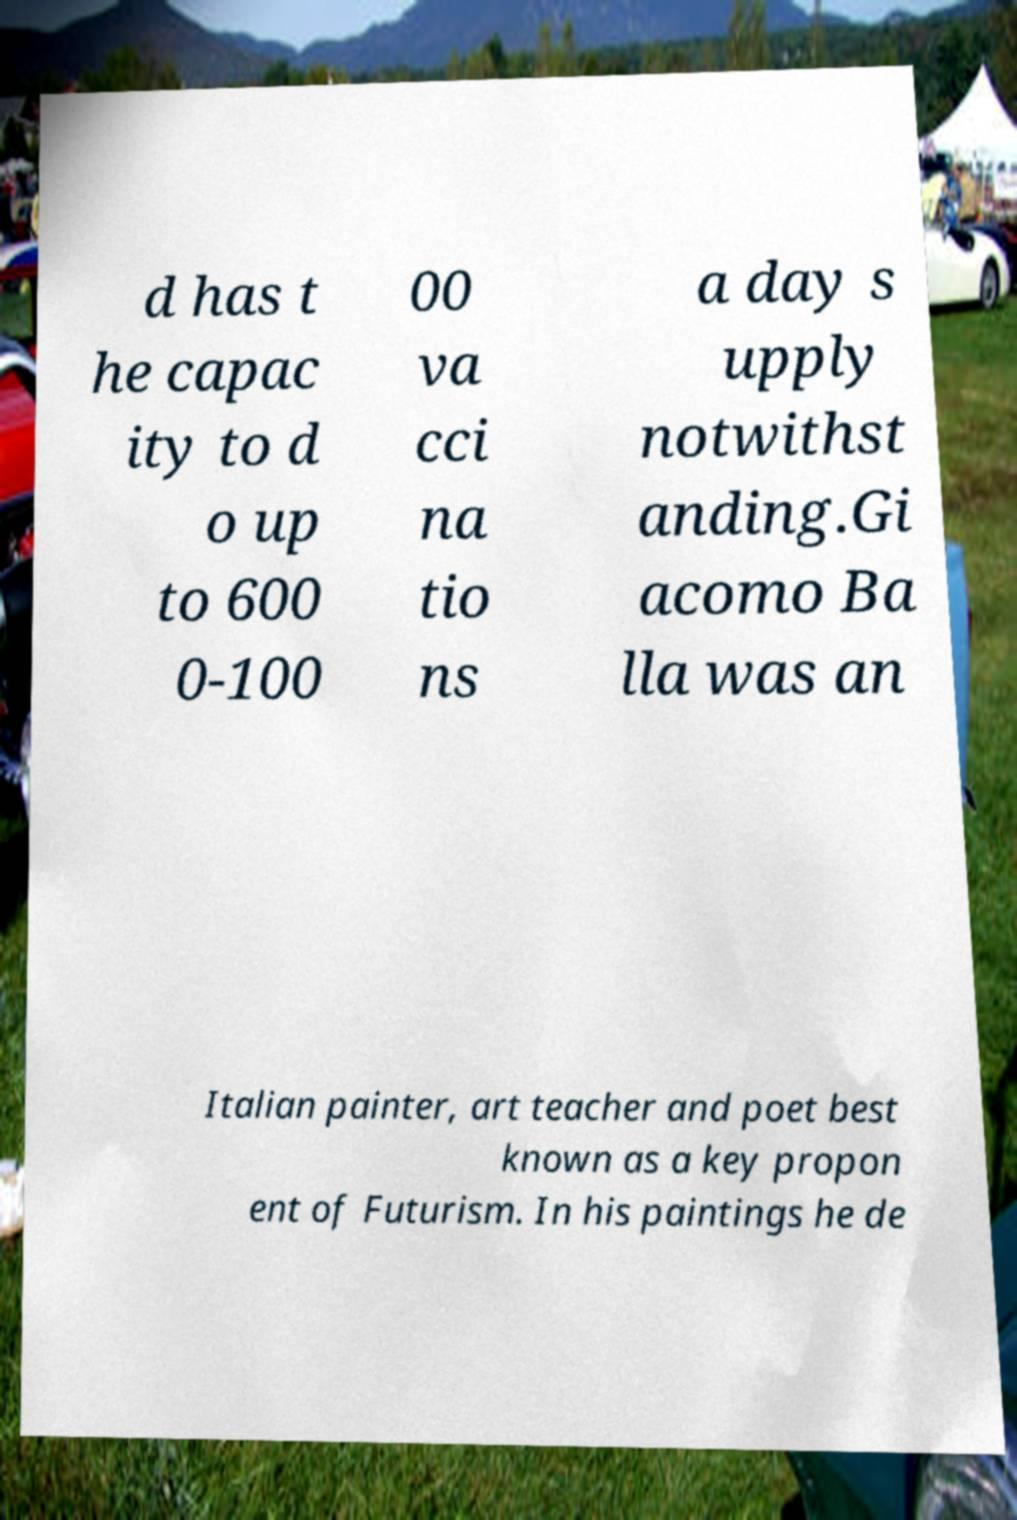What messages or text are displayed in this image? I need them in a readable, typed format. d has t he capac ity to d o up to 600 0-100 00 va cci na tio ns a day s upply notwithst anding.Gi acomo Ba lla was an Italian painter, art teacher and poet best known as a key propon ent of Futurism. In his paintings he de 